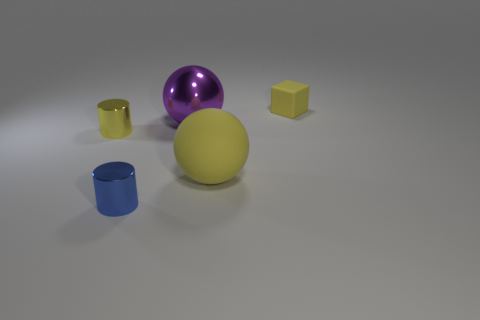What is the material of the tiny cylinder that is the same color as the rubber block?
Give a very brief answer. Metal. There is a matte thing that is in front of the large purple sphere; is it the same color as the cylinder that is behind the small blue shiny object?
Give a very brief answer. Yes. Is the shape of the metallic object to the right of the blue shiny cylinder the same as the small yellow thing that is right of the tiny yellow cylinder?
Provide a short and direct response. No. How many other objects are the same material as the tiny yellow cylinder?
Offer a very short reply. 2. Are there any yellow metal objects that are in front of the yellow rubber object that is behind the small object left of the blue metallic cylinder?
Provide a short and direct response. Yes. Does the blue cylinder have the same material as the big purple thing?
Give a very brief answer. Yes. Is there any other thing that has the same shape as the tiny rubber thing?
Provide a succinct answer. No. There is a tiny yellow object in front of the small object to the right of the large purple sphere; what is its material?
Provide a short and direct response. Metal. There is a yellow object in front of the yellow cylinder; how big is it?
Provide a succinct answer. Large. What color is the thing that is both right of the large purple metal object and left of the matte cube?
Give a very brief answer. Yellow. 